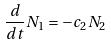<formula> <loc_0><loc_0><loc_500><loc_500>\frac { d } { d t } N _ { 1 } = - c _ { 2 } N _ { 2 }</formula> 